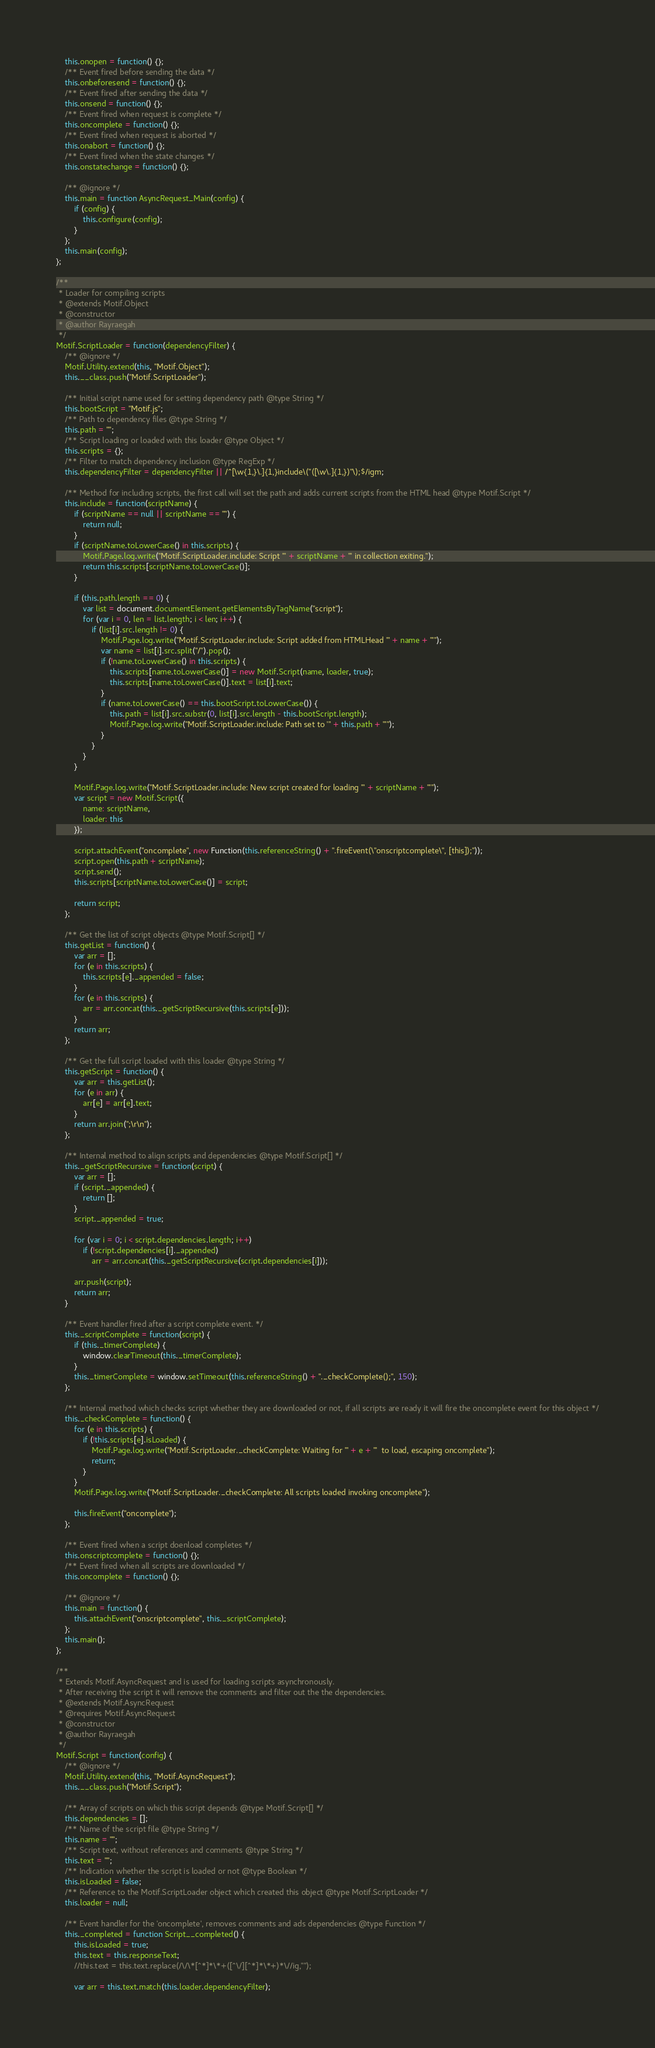<code> <loc_0><loc_0><loc_500><loc_500><_JavaScript_>    this.onopen = function() {};
    /** Event fired before sending the data */
    this.onbeforesend = function() {};
    /** Event fired after sending the data */
    this.onsend = function() {};
    /** Event fired when request is complete */
    this.oncomplete = function() {};
    /** Event fired when request is aborted */
    this.onabort = function() {};
    /** Event fired when the state changes */
    this.onstatechange = function() {};

    /** @ignore */
    this.main = function AsyncRequest_Main(config) {
        if (config) {
            this.configure(config);
        }
    };
    this.main(config);
};

/**
 * Loader for compiling scripts
 * @extends Motif.Object
 * @constructor
 * @author Rayraegah
 */
Motif.ScriptLoader = function(dependencyFilter) {
    /** @ignore */
    Motif.Utility.extend(this, "Motif.Object");
    this.__class.push("Motif.ScriptLoader");

    /** Initial script name used for setting dependency path @type String */
    this.bootScript = "Motif.js";
    /** Path to dependency files @type String */
    this.path = "";
    /** Script loading or loaded with this loader @type Object */
    this.scripts = {};
    /** Filter to match dependency inclusion @type RegExp */
    this.dependencyFilter = dependencyFilter || /^[\w{1,}\.]{1,}include\("([\w\.]{1,})"\);$/igm;

    /** Method for including scripts, the first call will set the path and adds current scripts from the HTML head @type Motif.Script */
    this.include = function(scriptName) {
        if (scriptName == null || scriptName == "") {
            return null;
        }
        if (scriptName.toLowerCase() in this.scripts) {
            Motif.Page.log.write("Motif.ScriptLoader.include: Script '" + scriptName + "' in collection exiting.");
            return this.scripts[scriptName.toLowerCase()];
        }

        if (this.path.length == 0) {
            var list = document.documentElement.getElementsByTagName("script");
            for (var i = 0, len = list.length; i < len; i++) {
                if (list[i].src.length != 0) {
                    Motif.Page.log.write("Motif.ScriptLoader.include: Script added from HTMLHead '" + name + "'");
                    var name = list[i].src.split("/").pop();
                    if (!name.toLowerCase() in this.scripts) {
                        this.scripts[name.toLowerCase()] = new Motif.Script(name, loader, true);
                        this.scripts[name.toLowerCase()].text = list[i].text;
                    }
                    if (name.toLowerCase() == this.bootScript.toLowerCase()) {
                        this.path = list[i].src.substr(0, list[i].src.length - this.bootScript.length);
                        Motif.Page.log.write("Motif.ScriptLoader.include: Path set to '" + this.path + "'");
                    }
                }
            }
        }

        Motif.Page.log.write("Motif.ScriptLoader.include: New script created for loading '" + scriptName + "'");
        var script = new Motif.Script({
            name: scriptName,
            loader: this
        });

        script.attachEvent("oncomplete", new Function(this.referenceString() + ".fireEvent(\"onscriptcomplete\", [this]);"));
        script.open(this.path + scriptName);
        script.send();
        this.scripts[scriptName.toLowerCase()] = script;

        return script;
    };

    /** Get the list of script objects @type Motif.Script[] */
    this.getList = function() {
        var arr = [];
        for (e in this.scripts) {
            this.scripts[e]._appended = false;
        }
        for (e in this.scripts) {
            arr = arr.concat(this._getScriptRecursive(this.scripts[e]));
        }
        return arr;
    };

    /** Get the full script loaded with this loader @type String */
    this.getScript = function() {
        var arr = this.getList();
        for (e in arr) {
            arr[e] = arr[e].text;
        }
        return arr.join(";\r\n");
    };

    /** Internal method to align scripts and dependencies @type Motif.Script[] */
    this._getScriptRecursive = function(script) {
        var arr = [];
        if (script._appended) {
            return [];
        }
        script._appended = true;

        for (var i = 0; i < script.dependencies.length; i++)
            if (!script.dependencies[i]._appended)
                arr = arr.concat(this._getScriptRecursive(script.dependencies[i]));

        arr.push(script);
        return arr;
    }

    /** Event handler fired after a script complete event. */
    this._scriptComplete = function(script) {
        if (this._timerComplete) {
            window.clearTimeout(this._timerComplete);
        }
        this._timerComplete = window.setTimeout(this.referenceString() + "._checkComplete();", 150);
    };

    /** Internal method which checks script whether they are downloaded or not, if all scripts are ready it will fire the oncomplete event for this object */
    this._checkComplete = function() {
        for (e in this.scripts) {
            if (!this.scripts[e].isLoaded) {
                Motif.Page.log.write("Motif.ScriptLoader._checkComplete: Waiting for '" + e + "'  to load, escaping oncomplete");
                return;
            }
        }
        Motif.Page.log.write("Motif.ScriptLoader._checkComplete: All scripts loaded invoking oncomplete");

        this.fireEvent("oncomplete");
    };

    /** Event fired when a script doenload completes */
    this.onscriptcomplete = function() {};
    /** Event fired when all scripts are downloaded */
    this.oncomplete = function() {};

    /** @ignore */
    this.main = function() {
        this.attachEvent("onscriptcomplete", this._scriptComplete);
    };
    this.main();
};

/**
 * Extends Motif.AsyncRequest and is used for loading scripts asynchronously.
 * After receiving the script it will remove the comments and filter out the the dependencies.
 * @extends Motif.AsyncRequest
 * @requires Motif.AsyncRequest
 * @constructor
 * @author Rayraegah
 */
Motif.Script = function(config) {
    /** @ignore */
    Motif.Utility.extend(this, "Motif.AsyncRequest");
    this.__class.push("Motif.Script");

    /** Array of scripts on which this script depends @type Motif.Script[] */
    this.dependencies = [];
    /** Name of the script file @type String */
    this.name = "";
    /** Script text, without references and comments @type String */
    this.text = "";
    /** Indication whether the script is loaded or not @type Boolean */
    this.isLoaded = false;
    /** Reference to the Motif.ScriptLoader object which created this object @type Motif.ScriptLoader */
    this.loader = null;

    /** Event handler for the 'oncomplete', removes comments and ads dependencies @type Function */
    this._completed = function Script__completed() {
        this.isLoaded = true;
        this.text = this.responseText;
        //this.text = this.text.replace(/\/\*[^*]*\*+([^\/][^*]*\*+)*\//ig,"");

        var arr = this.text.match(this.loader.dependencyFilter);</code> 